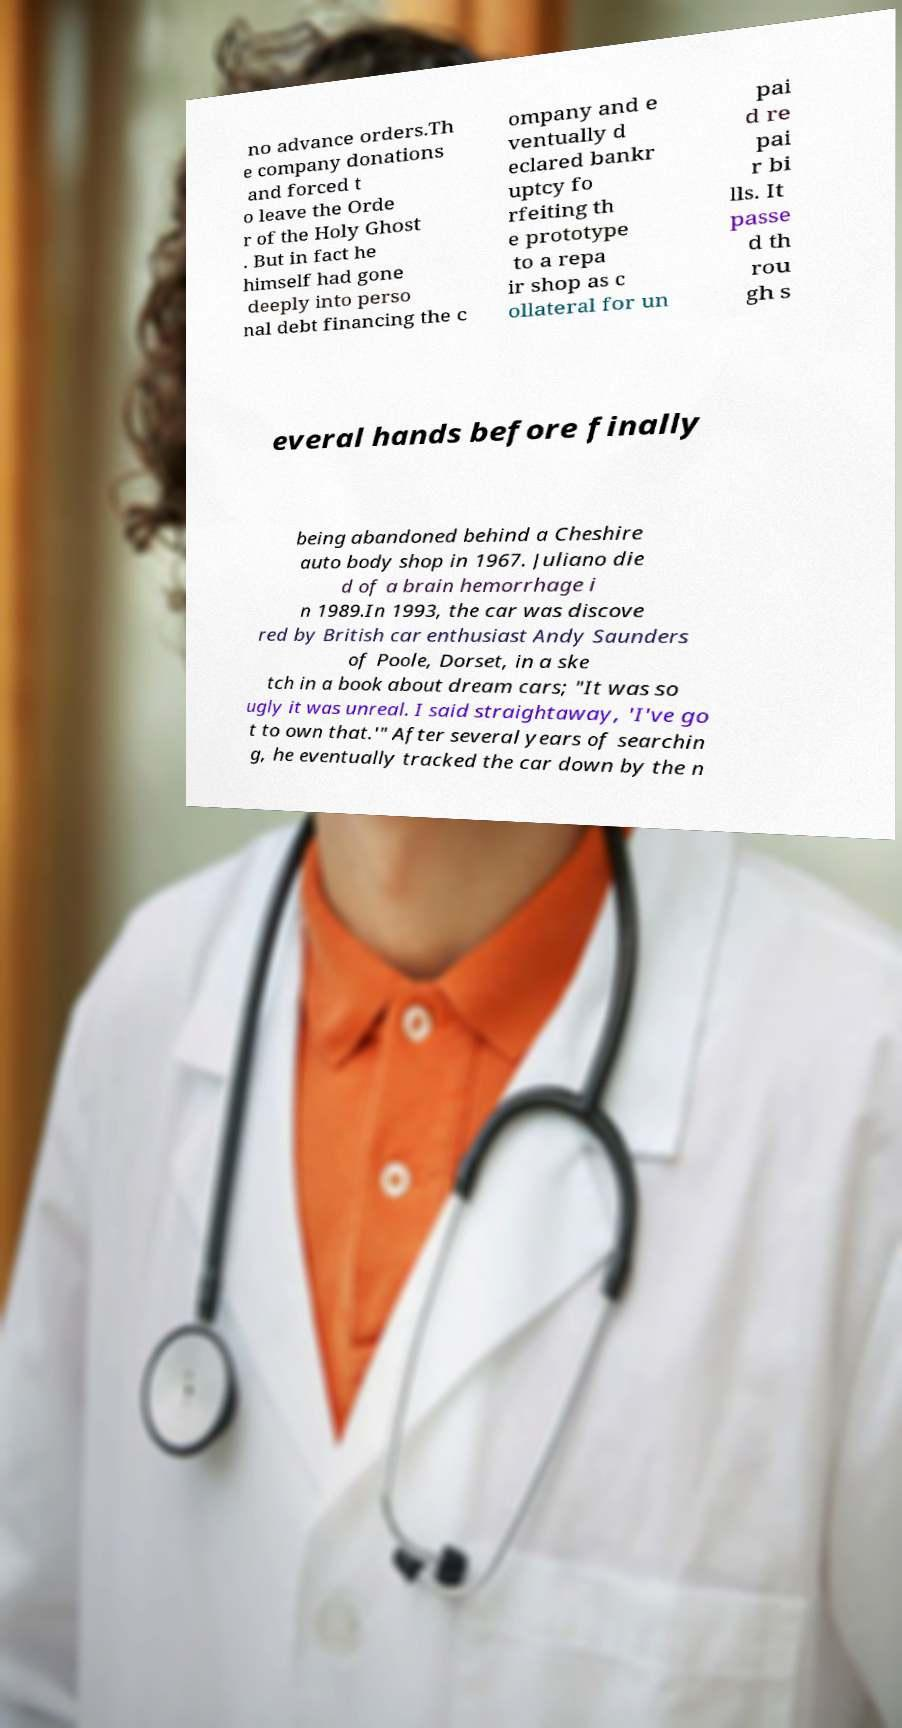Please identify and transcribe the text found in this image. no advance orders.Th e company donations and forced t o leave the Orde r of the Holy Ghost . But in fact he himself had gone deeply into perso nal debt financing the c ompany and e ventually d eclared bankr uptcy fo rfeiting th e prototype to a repa ir shop as c ollateral for un pai d re pai r bi lls. It passe d th rou gh s everal hands before finally being abandoned behind a Cheshire auto body shop in 1967. Juliano die d of a brain hemorrhage i n 1989.In 1993, the car was discove red by British car enthusiast Andy Saunders of Poole, Dorset, in a ske tch in a book about dream cars; "It was so ugly it was unreal. I said straightaway, 'I've go t to own that.'" After several years of searchin g, he eventually tracked the car down by the n 